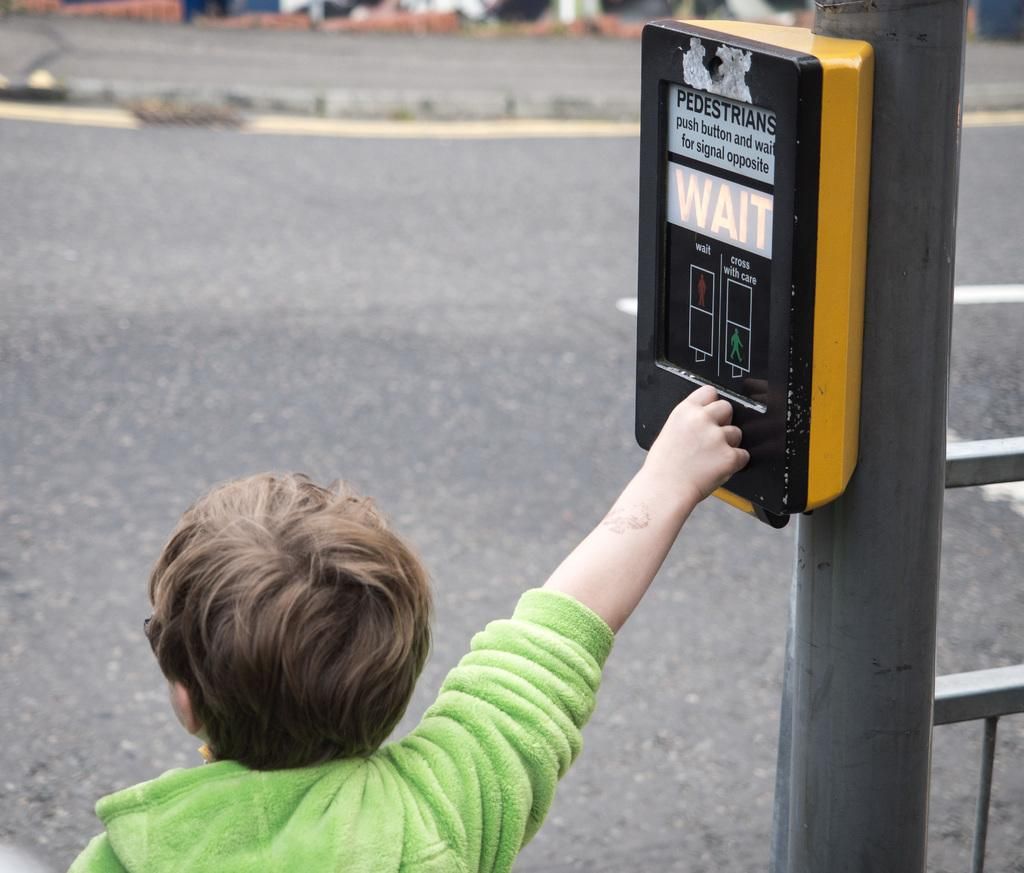Who is the main subject in the image? There is a boy in the image. What is the boy doing in the image? The boy is standing near a pole and catching an object. What type of pizzas is the boy eating in the image? There is no pizza present in the image; the boy is catching an object. What type of polish is the boy applying to the pole in the image? There is no polish or activity related to polishing in the image; the boy is simply standing near the pole and catching an object. 